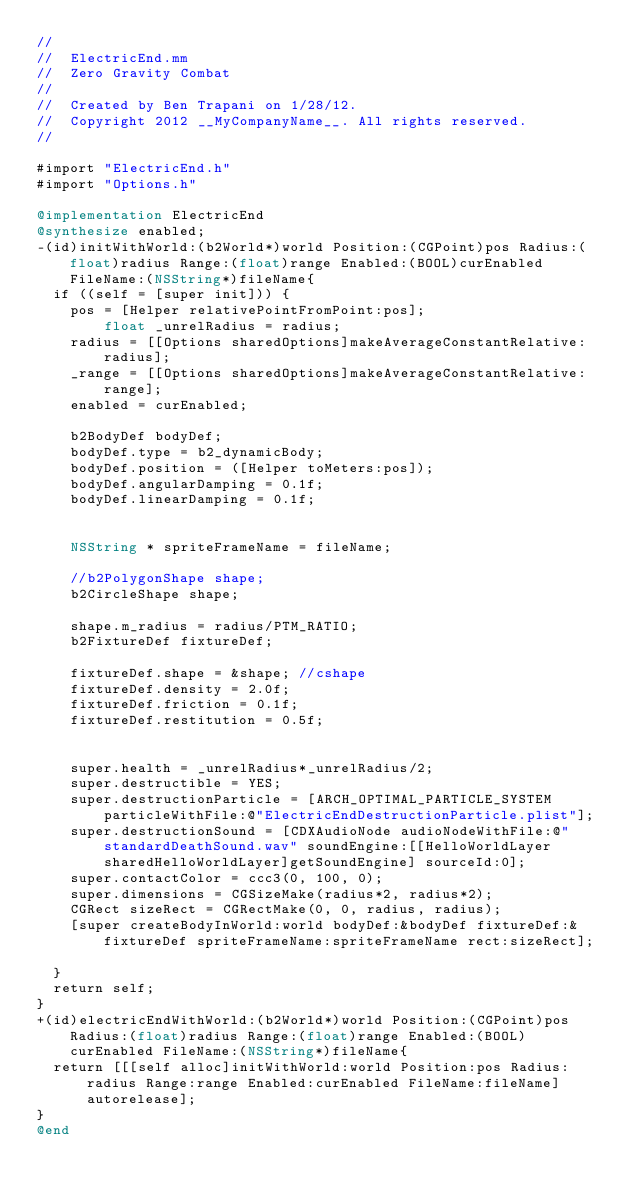Convert code to text. <code><loc_0><loc_0><loc_500><loc_500><_ObjectiveC_>//
//  ElectricEnd.mm
//  Zero Gravity Combat
//
//  Created by Ben Trapani on 1/28/12.
//  Copyright 2012 __MyCompanyName__. All rights reserved.
//

#import "ElectricEnd.h"
#import "Options.h"

@implementation ElectricEnd
@synthesize enabled;
-(id)initWithWorld:(b2World*)world Position:(CGPoint)pos Radius:(float)radius Range:(float)range Enabled:(BOOL)curEnabled FileName:(NSString*)fileName{
	if ((self = [super init])) {
		pos = [Helper relativePointFromPoint:pos];
        float _unrelRadius = radius;
		radius = [[Options sharedOptions]makeAverageConstantRelative:radius];
		_range = [[Options sharedOptions]makeAverageConstantRelative:range];
		enabled = curEnabled;
		
		b2BodyDef bodyDef;
		bodyDef.type = b2_dynamicBody;
		bodyDef.position = ([Helper toMeters:pos]);
		bodyDef.angularDamping = 0.1f;
		bodyDef.linearDamping = 0.1f;
		
		
		NSString * spriteFrameName = fileName;
		
		//b2PolygonShape shape;
		b2CircleShape shape;
		
		shape.m_radius = radius/PTM_RATIO;
		b2FixtureDef fixtureDef;
		
		fixtureDef.shape = &shape; //cshape
		fixtureDef.density = 2.0f;
		fixtureDef.friction = 0.1f;
		fixtureDef.restitution = 0.5f;
		
		
		super.health = _unrelRadius*_unrelRadius/2;
		super.destructible = YES;
		super.destructionParticle = [ARCH_OPTIMAL_PARTICLE_SYSTEM particleWithFile:@"ElectricEndDestructionParticle.plist"]; 
		super.destructionSound = [CDXAudioNode audioNodeWithFile:@"standardDeathSound.wav" soundEngine:[[HelloWorldLayer sharedHelloWorldLayer]getSoundEngine] sourceId:0];
		super.contactColor = ccc3(0, 100, 0);
		super.dimensions = CGSizeMake(radius*2, radius*2); 
		CGRect sizeRect = CGRectMake(0, 0, radius, radius);
		[super createBodyInWorld:world bodyDef:&bodyDef fixtureDef:&fixtureDef spriteFrameName:spriteFrameName rect:sizeRect]; 
		
	}
	return self;
}
+(id)electricEndWithWorld:(b2World*)world Position:(CGPoint)pos Radius:(float)radius Range:(float)range Enabled:(BOOL)curEnabled FileName:(NSString*)fileName{
	return [[[self alloc]initWithWorld:world Position:pos Radius:radius Range:range Enabled:curEnabled FileName:fileName]autorelease];
}
@end
</code> 